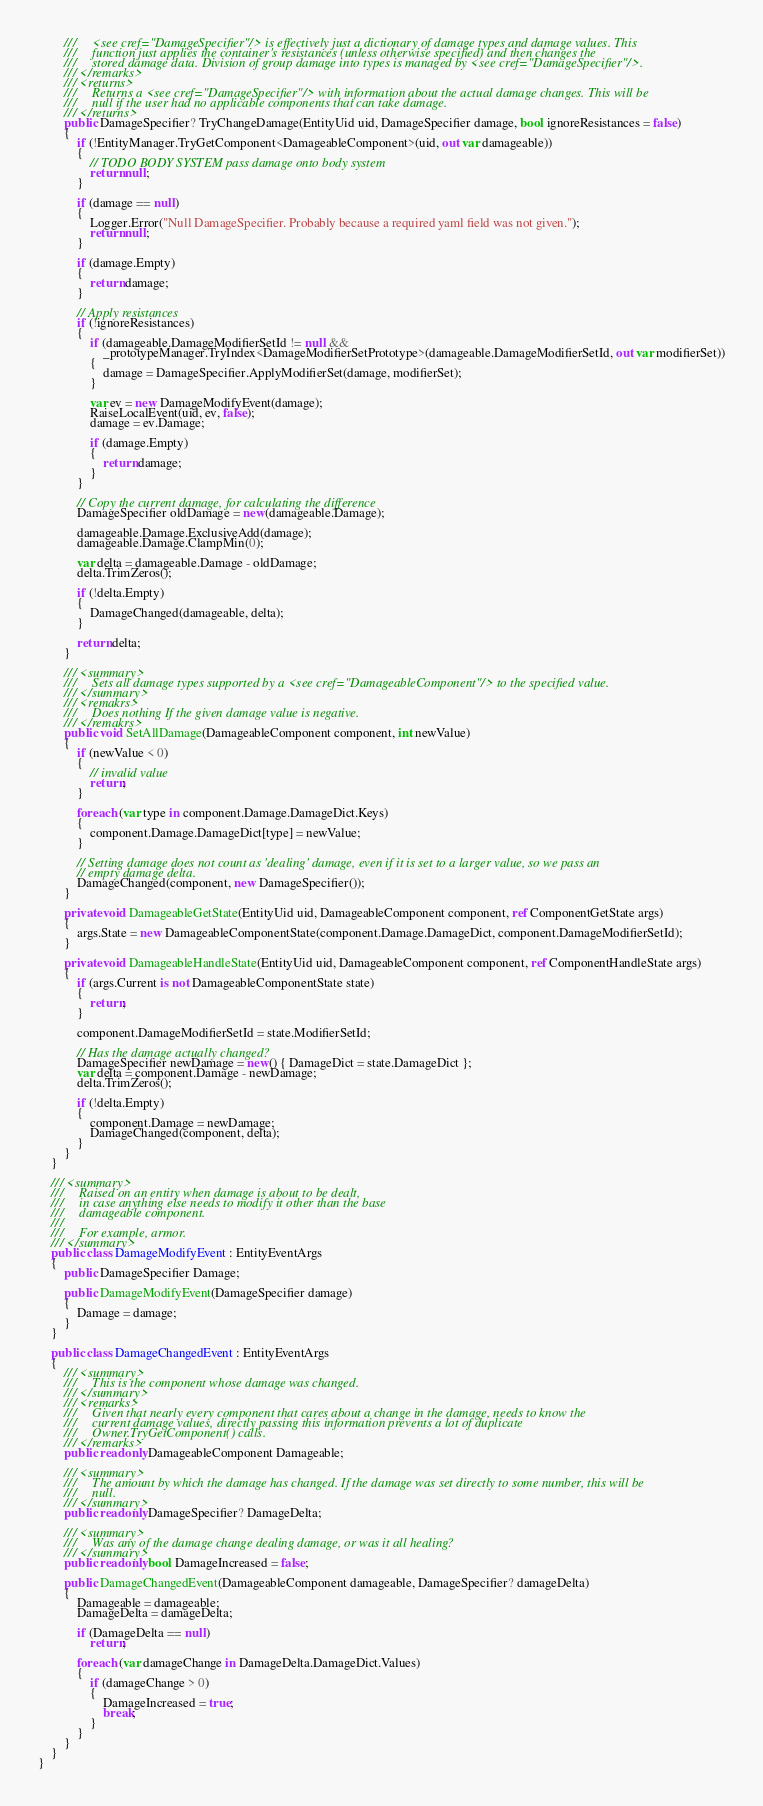Convert code to text. <code><loc_0><loc_0><loc_500><loc_500><_C#_>        ///     <see cref="DamageSpecifier"/> is effectively just a dictionary of damage types and damage values. This
        ///     function just applies the container's resistances (unless otherwise specified) and then changes the
        ///     stored damage data. Division of group damage into types is managed by <see cref="DamageSpecifier"/>.
        /// </remarks>
        /// <returns>
        ///     Returns a <see cref="DamageSpecifier"/> with information about the actual damage changes. This will be
        ///     null if the user had no applicable components that can take damage.
        /// </returns>
        public DamageSpecifier? TryChangeDamage(EntityUid uid, DamageSpecifier damage, bool ignoreResistances = false)
        {
            if (!EntityManager.TryGetComponent<DamageableComponent>(uid, out var damageable))
            {
                // TODO BODY SYSTEM pass damage onto body system
                return null;
            }

            if (damage == null)
            {
                Logger.Error("Null DamageSpecifier. Probably because a required yaml field was not given.");
                return null;
            }

            if (damage.Empty)
            {
                return damage;
            }

            // Apply resistances
            if (!ignoreResistances)
            {
                if (damageable.DamageModifierSetId != null &&
                    _prototypeManager.TryIndex<DamageModifierSetPrototype>(damageable.DamageModifierSetId, out var modifierSet))
                {
                    damage = DamageSpecifier.ApplyModifierSet(damage, modifierSet);
                }

                var ev = new DamageModifyEvent(damage);
                RaiseLocalEvent(uid, ev, false);
                damage = ev.Damage;

                if (damage.Empty)
                {
                    return damage;
                }
            }

            // Copy the current damage, for calculating the difference
            DamageSpecifier oldDamage = new(damageable.Damage);

            damageable.Damage.ExclusiveAdd(damage);
            damageable.Damage.ClampMin(0);

            var delta = damageable.Damage - oldDamage;
            delta.TrimZeros();

            if (!delta.Empty)
            {
                DamageChanged(damageable, delta);
            }

            return delta;
        }

        /// <summary>
        ///     Sets all damage types supported by a <see cref="DamageableComponent"/> to the specified value.
        /// </summary>
        /// <remakrs>
        ///     Does nothing If the given damage value is negative.
        /// </remakrs>
        public void SetAllDamage(DamageableComponent component, int newValue)
        {
            if (newValue < 0)
            {
                // invalid value
                return;
            }

            foreach (var type in component.Damage.DamageDict.Keys)
            {
                component.Damage.DamageDict[type] = newValue;
            }

            // Setting damage does not count as 'dealing' damage, even if it is set to a larger value, so we pass an
            // empty damage delta.
            DamageChanged(component, new DamageSpecifier());
        }

        private void DamageableGetState(EntityUid uid, DamageableComponent component, ref ComponentGetState args)
        {
            args.State = new DamageableComponentState(component.Damage.DamageDict, component.DamageModifierSetId);
        }

        private void DamageableHandleState(EntityUid uid, DamageableComponent component, ref ComponentHandleState args)
        {
            if (args.Current is not DamageableComponentState state)
            {
                return;
            }

            component.DamageModifierSetId = state.ModifierSetId;

            // Has the damage actually changed?
            DamageSpecifier newDamage = new() { DamageDict = state.DamageDict };
            var delta = component.Damage - newDamage;
            delta.TrimZeros();

            if (!delta.Empty)
            {
                component.Damage = newDamage;
                DamageChanged(component, delta);
            }
        }
    }

    /// <summary>
    ///     Raised on an entity when damage is about to be dealt,
    ///     in case anything else needs to modify it other than the base
    ///     damageable component.
    ///
    ///     For example, armor.
    /// </summary>
    public class DamageModifyEvent : EntityEventArgs
    {
        public DamageSpecifier Damage;

        public DamageModifyEvent(DamageSpecifier damage)
        {
            Damage = damage;
        }
    }

    public class DamageChangedEvent : EntityEventArgs
    {
        /// <summary>
        ///     This is the component whose damage was changed.
        /// </summary>
        /// <remarks>
        ///     Given that nearly every component that cares about a change in the damage, needs to know the
        ///     current damage values, directly passing this information prevents a lot of duplicate
        ///     Owner.TryGetComponent() calls.
        /// </remarks>
        public readonly DamageableComponent Damageable;

        /// <summary>
        ///     The amount by which the damage has changed. If the damage was set directly to some number, this will be
        ///     null.
        /// </summary>
        public readonly DamageSpecifier? DamageDelta;

        /// <summary>
        ///     Was any of the damage change dealing damage, or was it all healing?
        /// </summary>
        public readonly bool DamageIncreased = false;

        public DamageChangedEvent(DamageableComponent damageable, DamageSpecifier? damageDelta)
        {
            Damageable = damageable;
            DamageDelta = damageDelta;

            if (DamageDelta == null)
                return;

            foreach (var damageChange in DamageDelta.DamageDict.Values)
            {
                if (damageChange > 0)
                {
                    DamageIncreased = true;
                    break;
                }
            }
        }
    }
}
</code> 